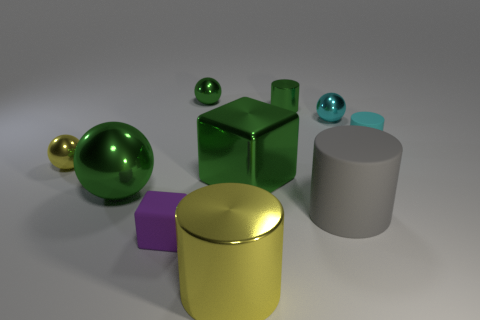Subtract all cylinders. How many objects are left? 6 Add 7 metal cubes. How many metal cubes exist? 8 Subtract 1 cyan spheres. How many objects are left? 9 Subtract all tiny matte cylinders. Subtract all small yellow shiny objects. How many objects are left? 8 Add 8 yellow shiny cylinders. How many yellow shiny cylinders are left? 9 